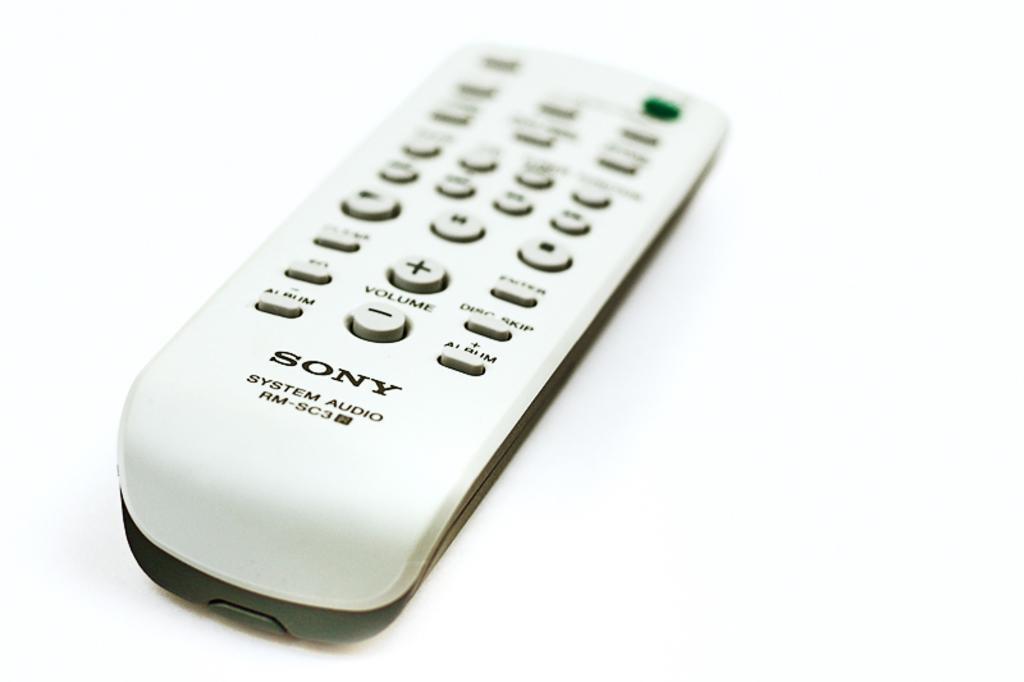<image>
Give a short and clear explanation of the subsequent image. A white Sony system audio remote control on a white background. 